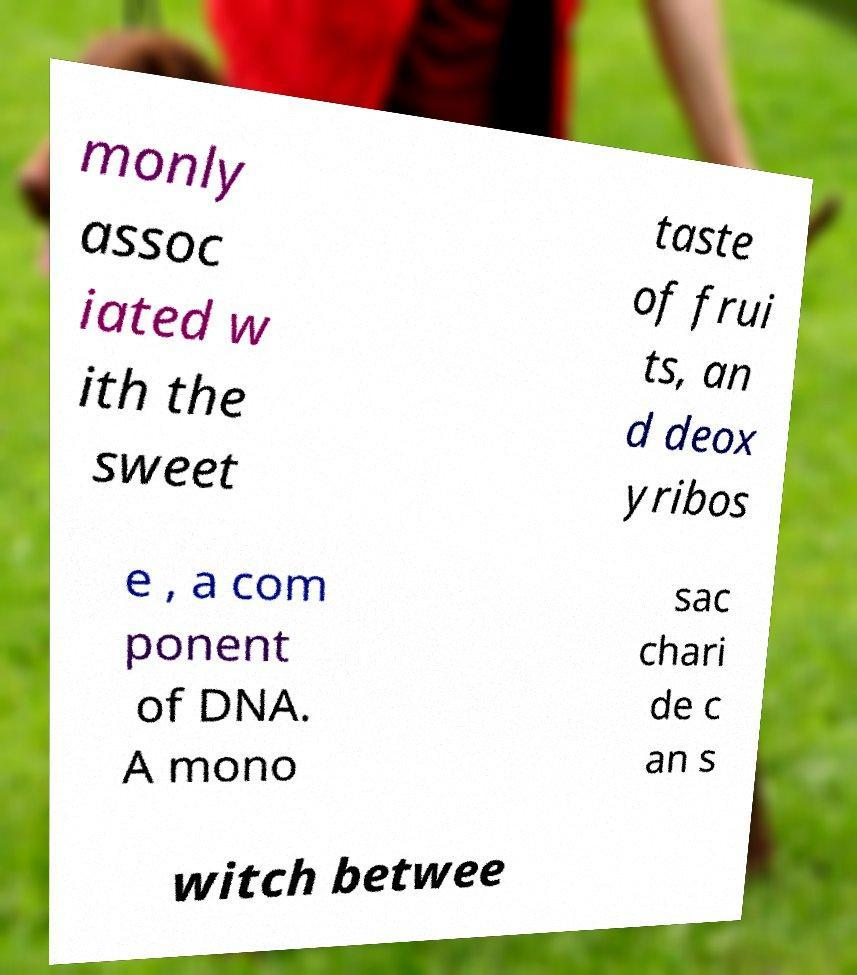There's text embedded in this image that I need extracted. Can you transcribe it verbatim? The text in the image says: 'monly associated with the sweet taste of fruits, and deoxyribose, a component of DNA. A monosaccharide can switch betwee'. It appears the text may be cut off or incomplete. 